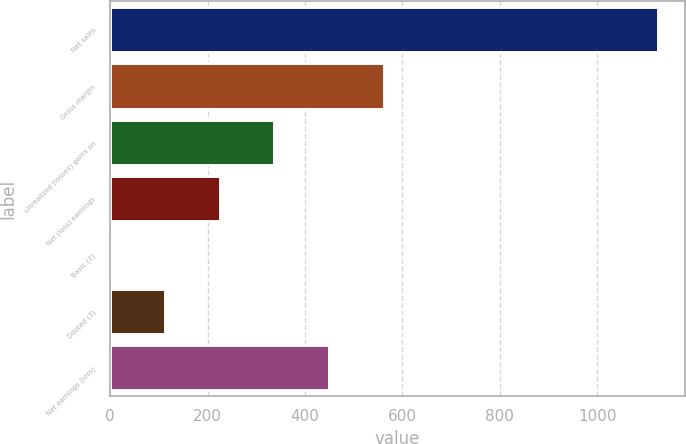Convert chart to OTSL. <chart><loc_0><loc_0><loc_500><loc_500><bar_chart><fcel>Net sales<fcel>Gross margin<fcel>Unrealized (losses) gains on<fcel>Net (loss) earnings<fcel>Basic (3)<fcel>Diluted (3)<fcel>Net earnings (loss)<nl><fcel>1124<fcel>562.01<fcel>337.21<fcel>224.81<fcel>0.01<fcel>112.41<fcel>449.61<nl></chart> 